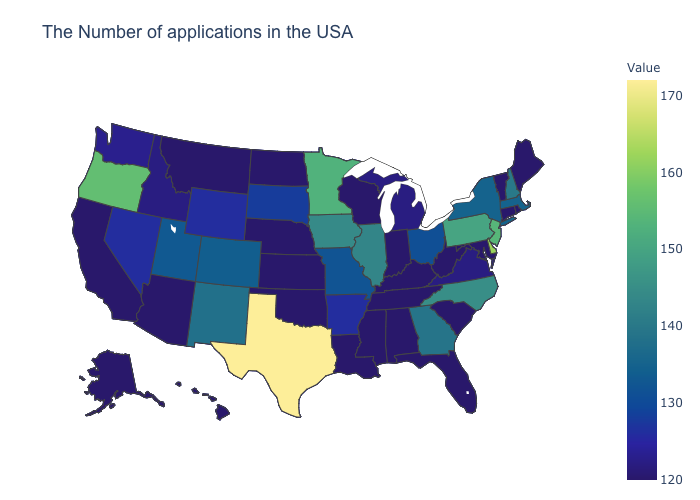Does the map have missing data?
Quick response, please. No. Among the states that border Illinois , does Iowa have the highest value?
Keep it brief. Yes. Does the map have missing data?
Keep it brief. No. Is the legend a continuous bar?
Answer briefly. Yes. Does Texas have the highest value in the South?
Concise answer only. Yes. Does Texas have the highest value in the South?
Answer briefly. Yes. 